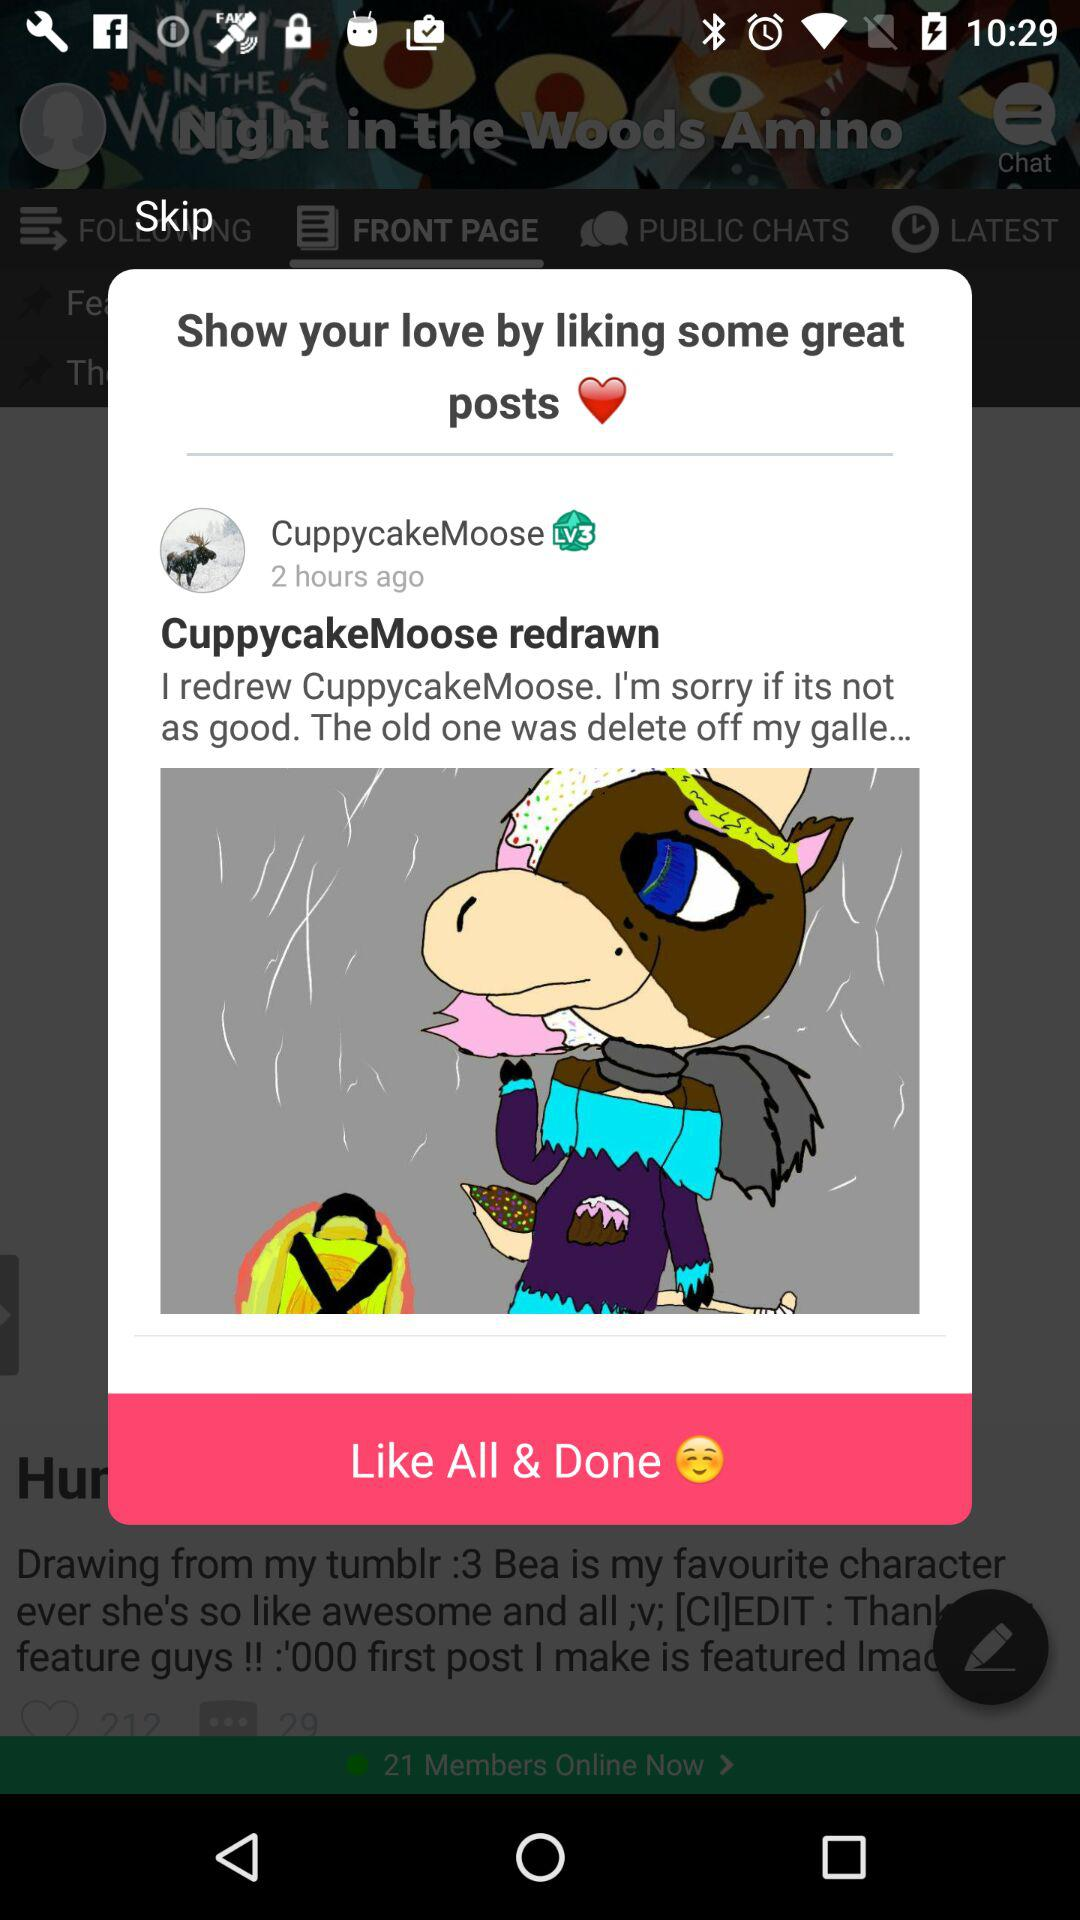What is the username? The username is "CuppycakeMoose". 